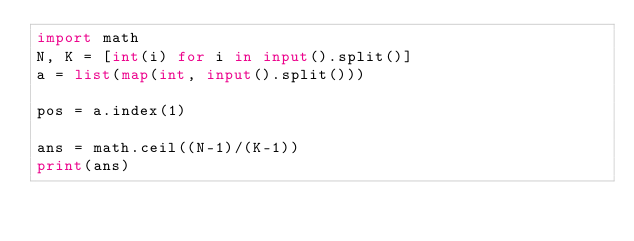Convert code to text. <code><loc_0><loc_0><loc_500><loc_500><_Python_>import math
N, K = [int(i) for i in input().split()]
a = list(map(int, input().split()))
 
pos = a.index(1)
 
ans = math.ceil((N-1)/(K-1))
print(ans)</code> 